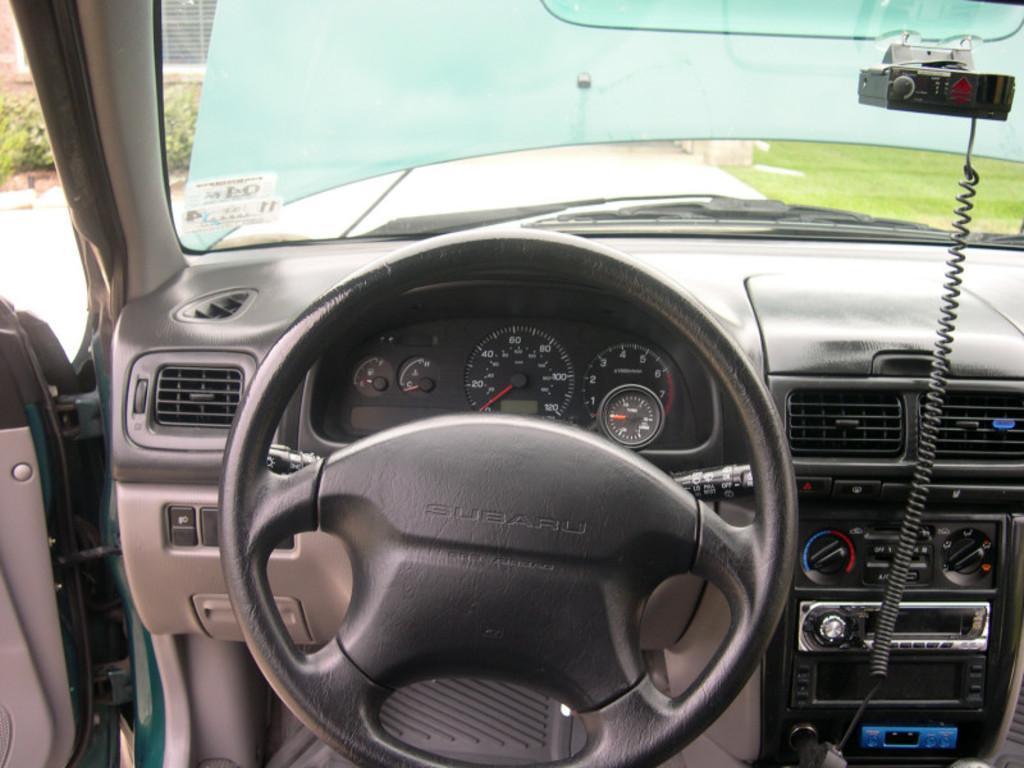Can you describe this image briefly? This picture is clicked inside the car. In the middle of the picture, we see a steering wheel and dashboard. Beside that, we see a music player. We see a glass from which we can see bonnet. On the left side, we see plants, window blind and a building. On the right side, we see grass. 